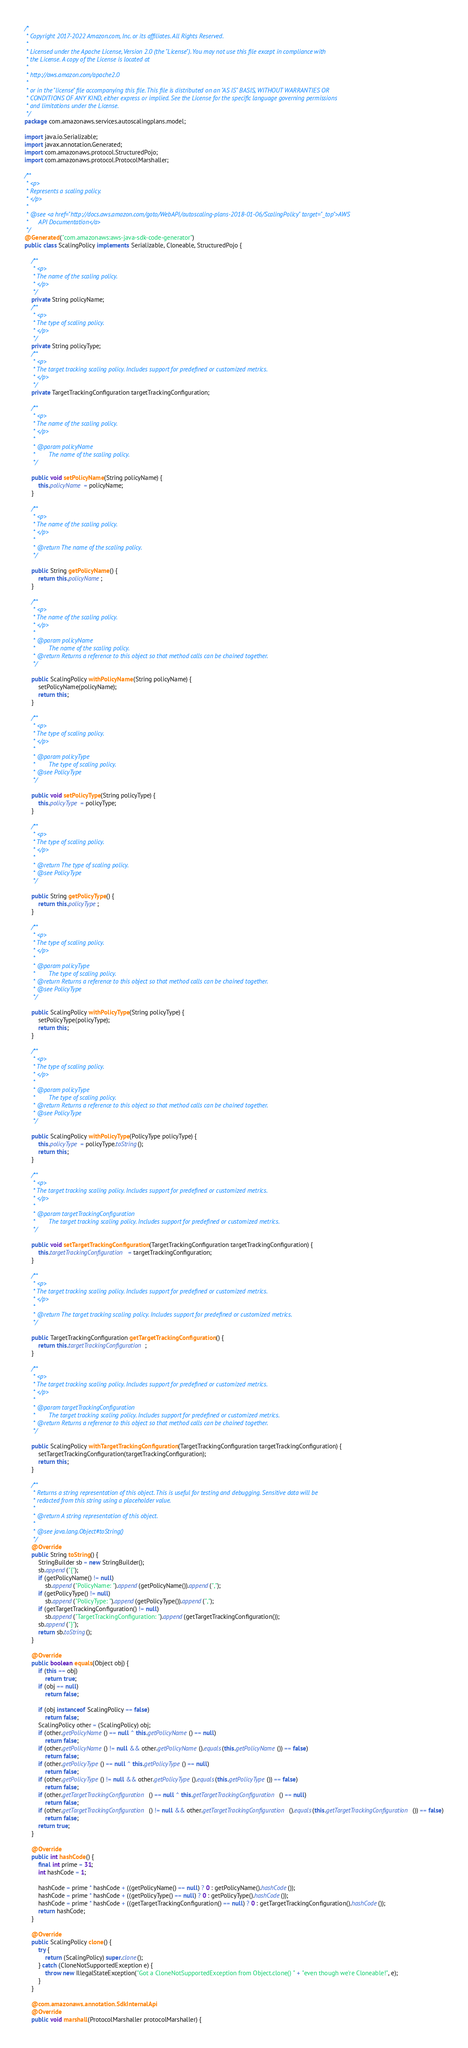Convert code to text. <code><loc_0><loc_0><loc_500><loc_500><_Java_>/*
 * Copyright 2017-2022 Amazon.com, Inc. or its affiliates. All Rights Reserved.
 * 
 * Licensed under the Apache License, Version 2.0 (the "License"). You may not use this file except in compliance with
 * the License. A copy of the License is located at
 * 
 * http://aws.amazon.com/apache2.0
 * 
 * or in the "license" file accompanying this file. This file is distributed on an "AS IS" BASIS, WITHOUT WARRANTIES OR
 * CONDITIONS OF ANY KIND, either express or implied. See the License for the specific language governing permissions
 * and limitations under the License.
 */
package com.amazonaws.services.autoscalingplans.model;

import java.io.Serializable;
import javax.annotation.Generated;
import com.amazonaws.protocol.StructuredPojo;
import com.amazonaws.protocol.ProtocolMarshaller;

/**
 * <p>
 * Represents a scaling policy.
 * </p>
 * 
 * @see <a href="http://docs.aws.amazon.com/goto/WebAPI/autoscaling-plans-2018-01-06/ScalingPolicy" target="_top">AWS
 *      API Documentation</a>
 */
@Generated("com.amazonaws:aws-java-sdk-code-generator")
public class ScalingPolicy implements Serializable, Cloneable, StructuredPojo {

    /**
     * <p>
     * The name of the scaling policy.
     * </p>
     */
    private String policyName;
    /**
     * <p>
     * The type of scaling policy.
     * </p>
     */
    private String policyType;
    /**
     * <p>
     * The target tracking scaling policy. Includes support for predefined or customized metrics.
     * </p>
     */
    private TargetTrackingConfiguration targetTrackingConfiguration;

    /**
     * <p>
     * The name of the scaling policy.
     * </p>
     * 
     * @param policyName
     *        The name of the scaling policy.
     */

    public void setPolicyName(String policyName) {
        this.policyName = policyName;
    }

    /**
     * <p>
     * The name of the scaling policy.
     * </p>
     * 
     * @return The name of the scaling policy.
     */

    public String getPolicyName() {
        return this.policyName;
    }

    /**
     * <p>
     * The name of the scaling policy.
     * </p>
     * 
     * @param policyName
     *        The name of the scaling policy.
     * @return Returns a reference to this object so that method calls can be chained together.
     */

    public ScalingPolicy withPolicyName(String policyName) {
        setPolicyName(policyName);
        return this;
    }

    /**
     * <p>
     * The type of scaling policy.
     * </p>
     * 
     * @param policyType
     *        The type of scaling policy.
     * @see PolicyType
     */

    public void setPolicyType(String policyType) {
        this.policyType = policyType;
    }

    /**
     * <p>
     * The type of scaling policy.
     * </p>
     * 
     * @return The type of scaling policy.
     * @see PolicyType
     */

    public String getPolicyType() {
        return this.policyType;
    }

    /**
     * <p>
     * The type of scaling policy.
     * </p>
     * 
     * @param policyType
     *        The type of scaling policy.
     * @return Returns a reference to this object so that method calls can be chained together.
     * @see PolicyType
     */

    public ScalingPolicy withPolicyType(String policyType) {
        setPolicyType(policyType);
        return this;
    }

    /**
     * <p>
     * The type of scaling policy.
     * </p>
     * 
     * @param policyType
     *        The type of scaling policy.
     * @return Returns a reference to this object so that method calls can be chained together.
     * @see PolicyType
     */

    public ScalingPolicy withPolicyType(PolicyType policyType) {
        this.policyType = policyType.toString();
        return this;
    }

    /**
     * <p>
     * The target tracking scaling policy. Includes support for predefined or customized metrics.
     * </p>
     * 
     * @param targetTrackingConfiguration
     *        The target tracking scaling policy. Includes support for predefined or customized metrics.
     */

    public void setTargetTrackingConfiguration(TargetTrackingConfiguration targetTrackingConfiguration) {
        this.targetTrackingConfiguration = targetTrackingConfiguration;
    }

    /**
     * <p>
     * The target tracking scaling policy. Includes support for predefined or customized metrics.
     * </p>
     * 
     * @return The target tracking scaling policy. Includes support for predefined or customized metrics.
     */

    public TargetTrackingConfiguration getTargetTrackingConfiguration() {
        return this.targetTrackingConfiguration;
    }

    /**
     * <p>
     * The target tracking scaling policy. Includes support for predefined or customized metrics.
     * </p>
     * 
     * @param targetTrackingConfiguration
     *        The target tracking scaling policy. Includes support for predefined or customized metrics.
     * @return Returns a reference to this object so that method calls can be chained together.
     */

    public ScalingPolicy withTargetTrackingConfiguration(TargetTrackingConfiguration targetTrackingConfiguration) {
        setTargetTrackingConfiguration(targetTrackingConfiguration);
        return this;
    }

    /**
     * Returns a string representation of this object. This is useful for testing and debugging. Sensitive data will be
     * redacted from this string using a placeholder value.
     *
     * @return A string representation of this object.
     *
     * @see java.lang.Object#toString()
     */
    @Override
    public String toString() {
        StringBuilder sb = new StringBuilder();
        sb.append("{");
        if (getPolicyName() != null)
            sb.append("PolicyName: ").append(getPolicyName()).append(",");
        if (getPolicyType() != null)
            sb.append("PolicyType: ").append(getPolicyType()).append(",");
        if (getTargetTrackingConfiguration() != null)
            sb.append("TargetTrackingConfiguration: ").append(getTargetTrackingConfiguration());
        sb.append("}");
        return sb.toString();
    }

    @Override
    public boolean equals(Object obj) {
        if (this == obj)
            return true;
        if (obj == null)
            return false;

        if (obj instanceof ScalingPolicy == false)
            return false;
        ScalingPolicy other = (ScalingPolicy) obj;
        if (other.getPolicyName() == null ^ this.getPolicyName() == null)
            return false;
        if (other.getPolicyName() != null && other.getPolicyName().equals(this.getPolicyName()) == false)
            return false;
        if (other.getPolicyType() == null ^ this.getPolicyType() == null)
            return false;
        if (other.getPolicyType() != null && other.getPolicyType().equals(this.getPolicyType()) == false)
            return false;
        if (other.getTargetTrackingConfiguration() == null ^ this.getTargetTrackingConfiguration() == null)
            return false;
        if (other.getTargetTrackingConfiguration() != null && other.getTargetTrackingConfiguration().equals(this.getTargetTrackingConfiguration()) == false)
            return false;
        return true;
    }

    @Override
    public int hashCode() {
        final int prime = 31;
        int hashCode = 1;

        hashCode = prime * hashCode + ((getPolicyName() == null) ? 0 : getPolicyName().hashCode());
        hashCode = prime * hashCode + ((getPolicyType() == null) ? 0 : getPolicyType().hashCode());
        hashCode = prime * hashCode + ((getTargetTrackingConfiguration() == null) ? 0 : getTargetTrackingConfiguration().hashCode());
        return hashCode;
    }

    @Override
    public ScalingPolicy clone() {
        try {
            return (ScalingPolicy) super.clone();
        } catch (CloneNotSupportedException e) {
            throw new IllegalStateException("Got a CloneNotSupportedException from Object.clone() " + "even though we're Cloneable!", e);
        }
    }

    @com.amazonaws.annotation.SdkInternalApi
    @Override
    public void marshall(ProtocolMarshaller protocolMarshaller) {</code> 